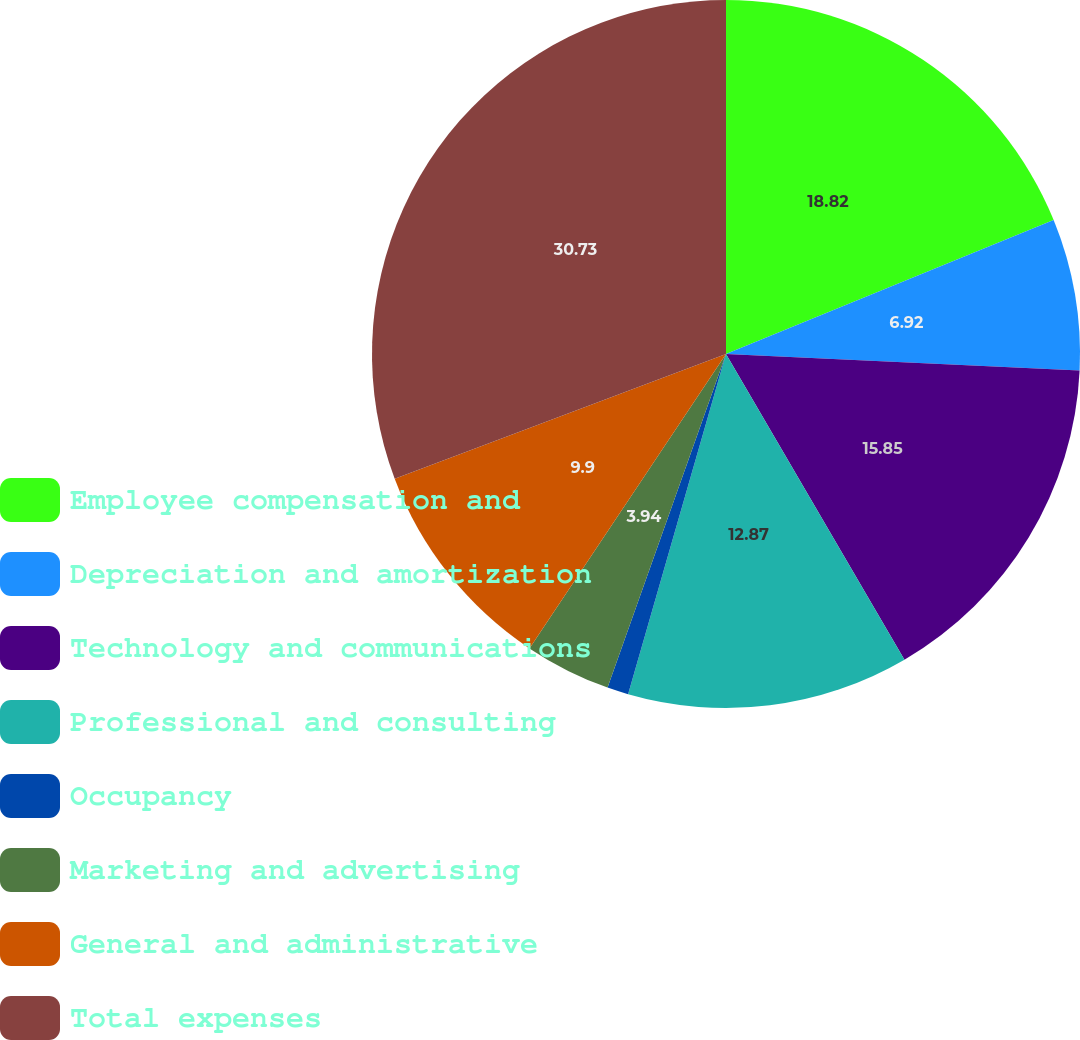<chart> <loc_0><loc_0><loc_500><loc_500><pie_chart><fcel>Employee compensation and<fcel>Depreciation and amortization<fcel>Technology and communications<fcel>Professional and consulting<fcel>Occupancy<fcel>Marketing and advertising<fcel>General and administrative<fcel>Total expenses<nl><fcel>18.82%<fcel>6.92%<fcel>15.85%<fcel>12.87%<fcel>0.97%<fcel>3.94%<fcel>9.9%<fcel>30.73%<nl></chart> 